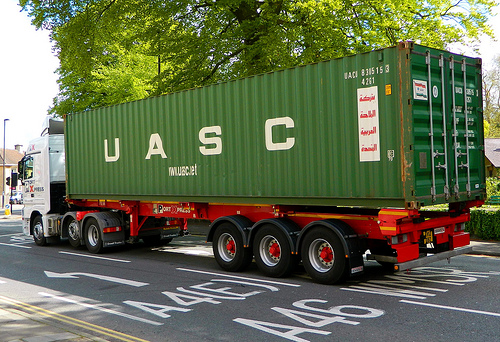What color is the vehicle the house is to the right of? The house is to the right of a green vehicle. 